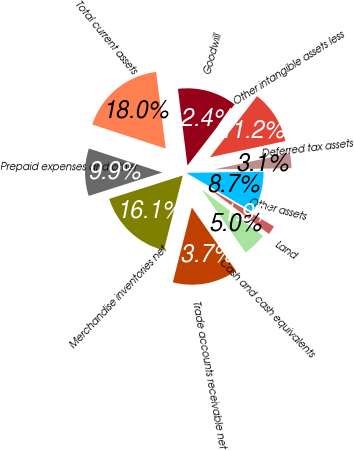<chart> <loc_0><loc_0><loc_500><loc_500><pie_chart><fcel>Cash and cash equivalents<fcel>Trade accounts receivable net<fcel>Merchandise inventories net<fcel>Prepaid expenses and other<fcel>Total current assets<fcel>Goodwill<fcel>Other intangible assets less<fcel>Deferred tax assets<fcel>Other assets<fcel>Land<nl><fcel>4.98%<fcel>13.66%<fcel>16.14%<fcel>9.94%<fcel>18.0%<fcel>12.42%<fcel>11.18%<fcel>3.12%<fcel>8.7%<fcel>1.87%<nl></chart> 